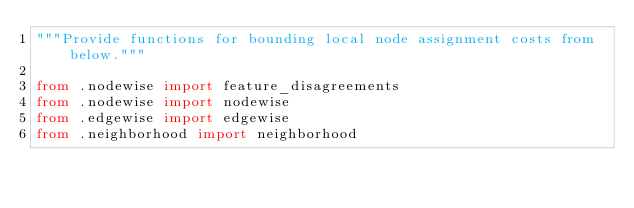<code> <loc_0><loc_0><loc_500><loc_500><_Python_>"""Provide functions for bounding local node assignment costs from below."""

from .nodewise import feature_disagreements
from .nodewise import nodewise
from .edgewise import edgewise
from .neighborhood import neighborhood
</code> 